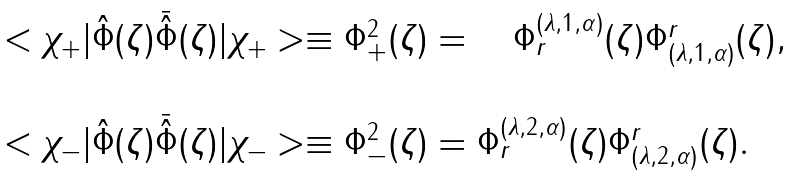<formula> <loc_0><loc_0><loc_500><loc_500>\begin{array} { l } < \chi _ { + } | \hat { \Phi } ( \zeta ) \bar { \hat { \Phi } } ( \zeta ) | \chi _ { + } > \equiv \Phi ^ { 2 } _ { + } ( \zeta ) = \quad \Phi _ { r } ^ { ( \lambda , 1 , \alpha ) } ( \zeta ) \Phi ^ { r } _ { ( \lambda , 1 , \alpha ) } ( \zeta ) , \\ \\ < \chi _ { - } | \hat { \Phi } ( \zeta ) \bar { \hat { \Phi } } ( \zeta ) | \chi _ { - } > \equiv \Phi ^ { 2 } _ { - } ( \zeta ) = \Phi _ { r } ^ { ( \lambda , 2 , \alpha ) } ( \zeta ) \Phi ^ { r } _ { ( \lambda , 2 , \alpha ) } ( \zeta ) . \end{array}</formula> 